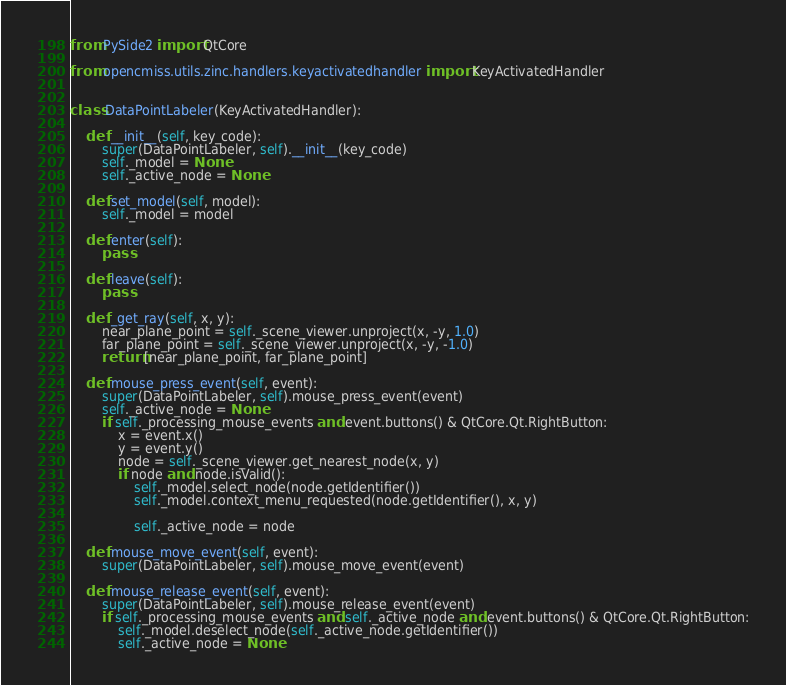<code> <loc_0><loc_0><loc_500><loc_500><_Python_>from PySide2 import QtCore

from opencmiss.utils.zinc.handlers.keyactivatedhandler import KeyActivatedHandler


class DataPointLabeler(KeyActivatedHandler):

    def __init__(self, key_code):
        super(DataPointLabeler, self).__init__(key_code)
        self._model = None
        self._active_node = None

    def set_model(self, model):
        self._model = model

    def enter(self):
        pass

    def leave(self):
        pass

    def _get_ray(self, x, y):
        near_plane_point = self._scene_viewer.unproject(x, -y, 1.0)
        far_plane_point = self._scene_viewer.unproject(x, -y, -1.0)
        return [near_plane_point, far_plane_point]

    def mouse_press_event(self, event):
        super(DataPointLabeler, self).mouse_press_event(event)
        self._active_node = None
        if self._processing_mouse_events and event.buttons() & QtCore.Qt.RightButton:
            x = event.x()
            y = event.y()
            node = self._scene_viewer.get_nearest_node(x, y)
            if node and node.isValid():
                self._model.select_node(node.getIdentifier())
                self._model.context_menu_requested(node.getIdentifier(), x, y)

                self._active_node = node

    def mouse_move_event(self, event):
        super(DataPointLabeler, self).mouse_move_event(event)

    def mouse_release_event(self, event):
        super(DataPointLabeler, self).mouse_release_event(event)
        if self._processing_mouse_events and self._active_node and event.buttons() & QtCore.Qt.RightButton:
            self._model.deselect_node(self._active_node.getIdentifier())
            self._active_node = None
</code> 